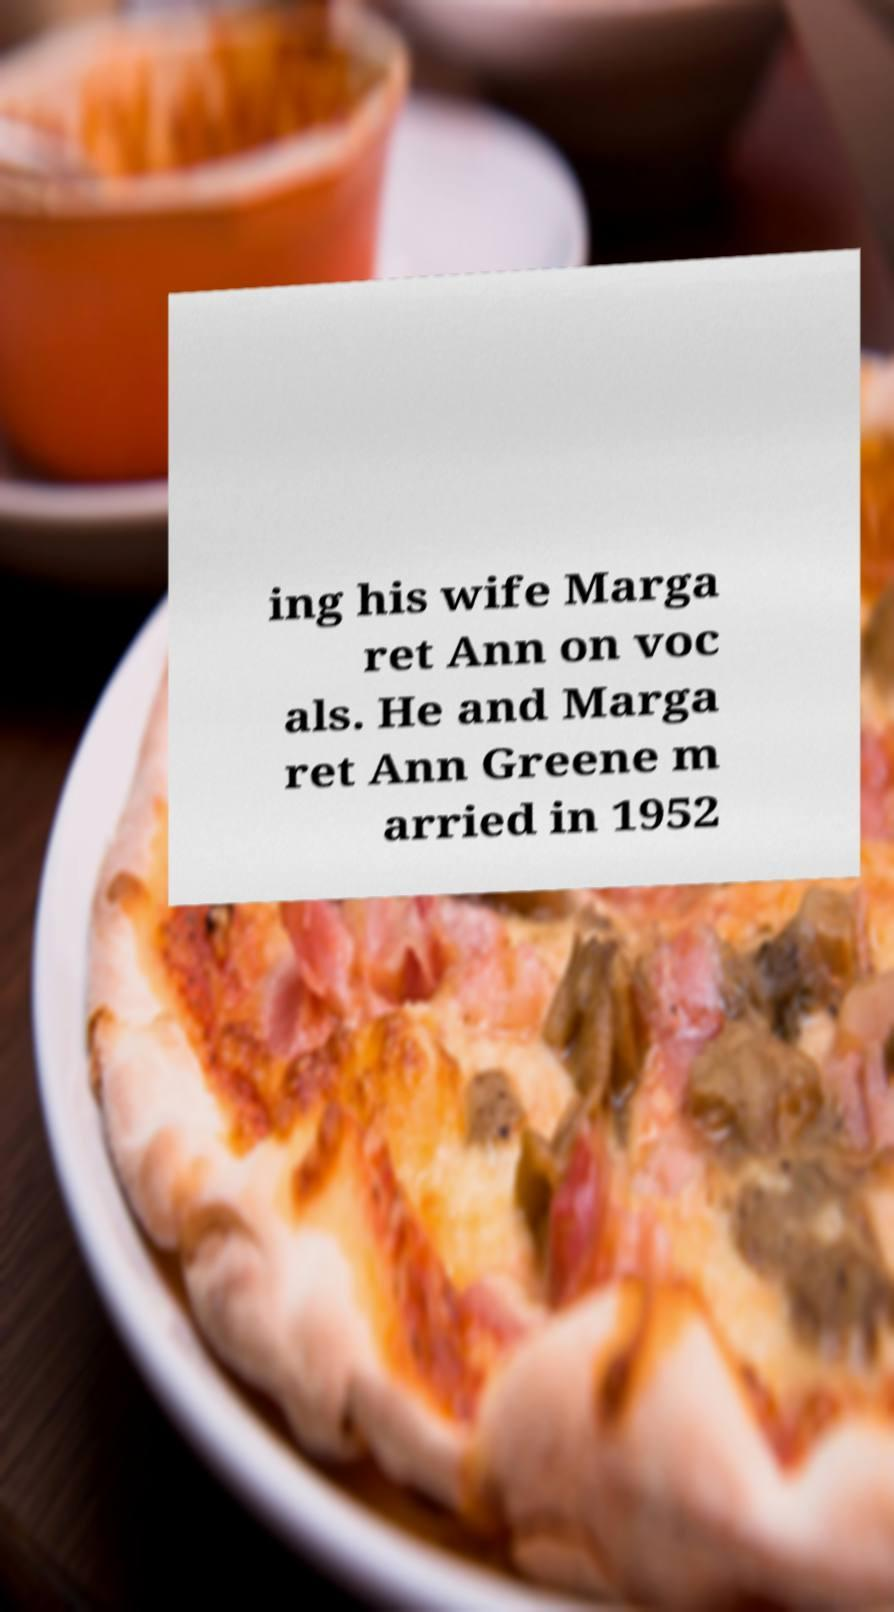Please identify and transcribe the text found in this image. ing his wife Marga ret Ann on voc als. He and Marga ret Ann Greene m arried in 1952 